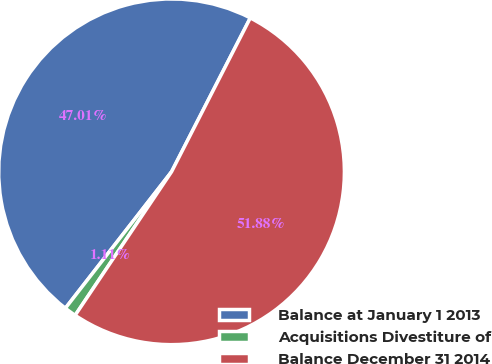Convert chart to OTSL. <chart><loc_0><loc_0><loc_500><loc_500><pie_chart><fcel>Balance at January 1 2013<fcel>Acquisitions Divestiture of<fcel>Balance December 31 2014<nl><fcel>47.01%<fcel>1.11%<fcel>51.89%<nl></chart> 